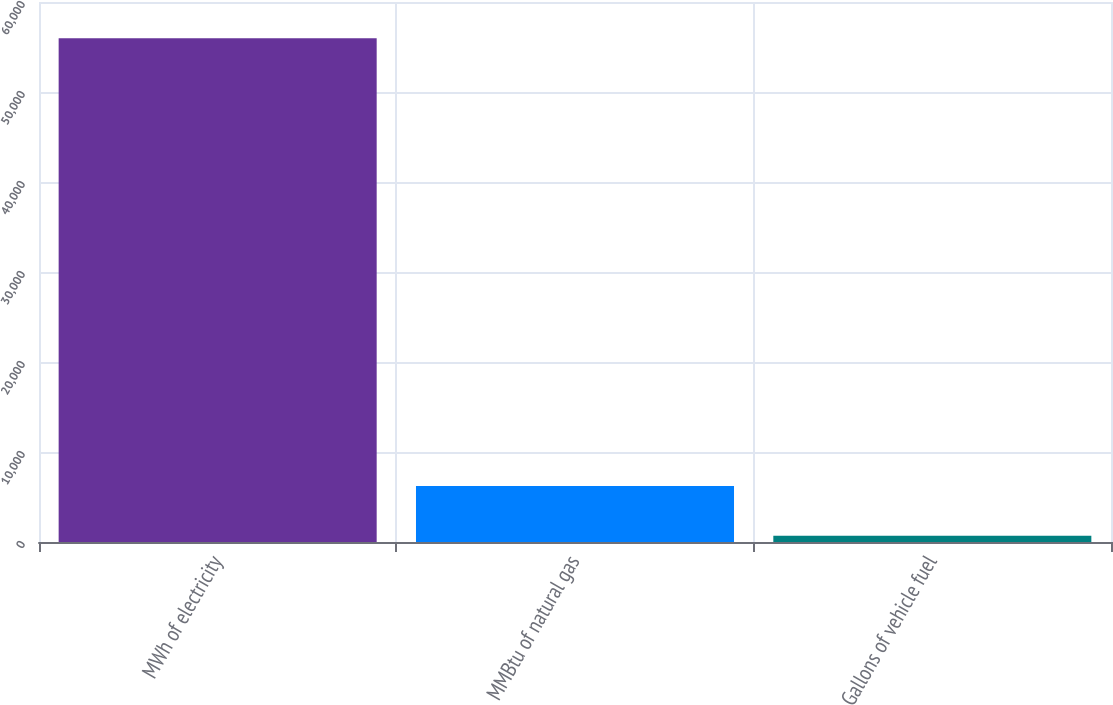<chart> <loc_0><loc_0><loc_500><loc_500><bar_chart><fcel>MWh of electricity<fcel>MMBtu of natural gas<fcel>Gallons of vehicle fuel<nl><fcel>55976<fcel>6211.4<fcel>682<nl></chart> 